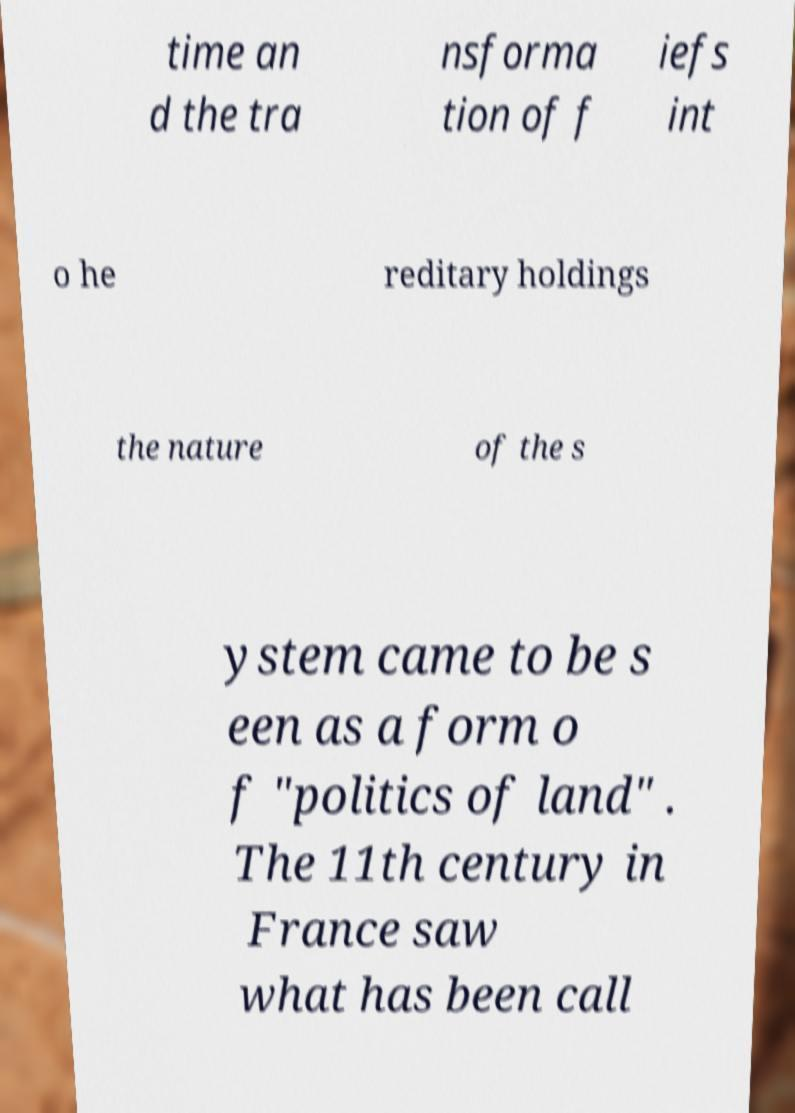Could you extract and type out the text from this image? time an d the tra nsforma tion of f iefs int o he reditary holdings the nature of the s ystem came to be s een as a form o f "politics of land" . The 11th century in France saw what has been call 